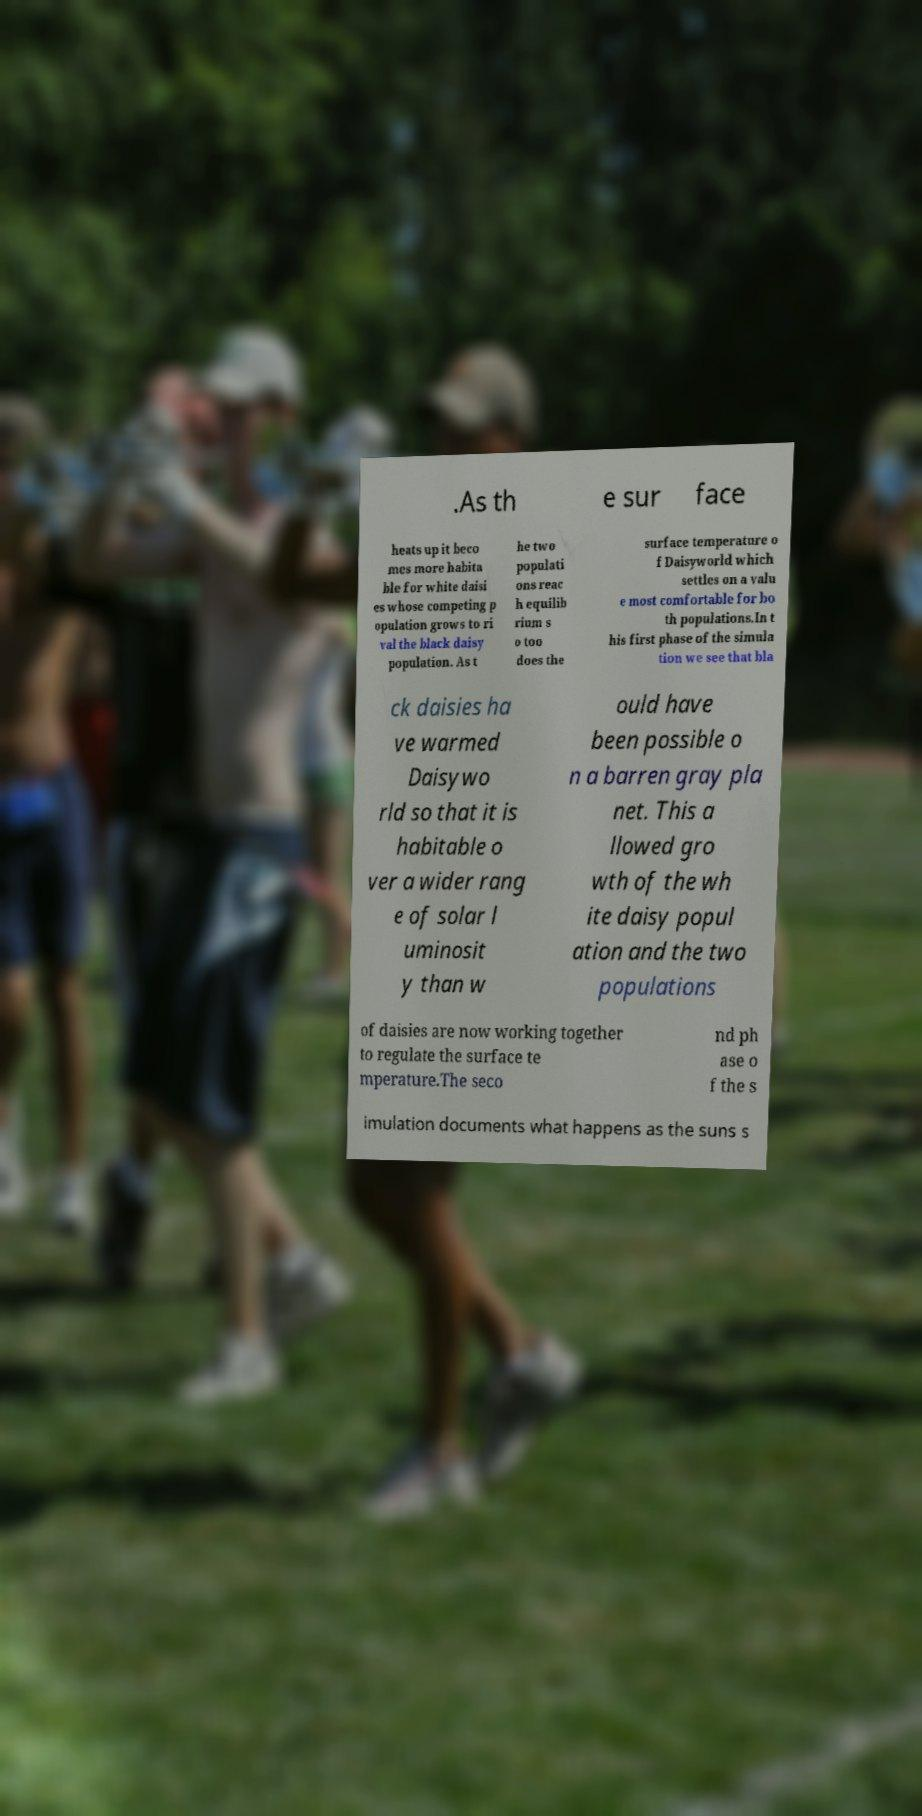There's text embedded in this image that I need extracted. Can you transcribe it verbatim? .As th e sur face heats up it beco mes more habita ble for white daisi es whose competing p opulation grows to ri val the black daisy population. As t he two populati ons reac h equilib rium s o too does the surface temperature o f Daisyworld which settles on a valu e most comfortable for bo th populations.In t his first phase of the simula tion we see that bla ck daisies ha ve warmed Daisywo rld so that it is habitable o ver a wider rang e of solar l uminosit y than w ould have been possible o n a barren gray pla net. This a llowed gro wth of the wh ite daisy popul ation and the two populations of daisies are now working together to regulate the surface te mperature.The seco nd ph ase o f the s imulation documents what happens as the suns s 